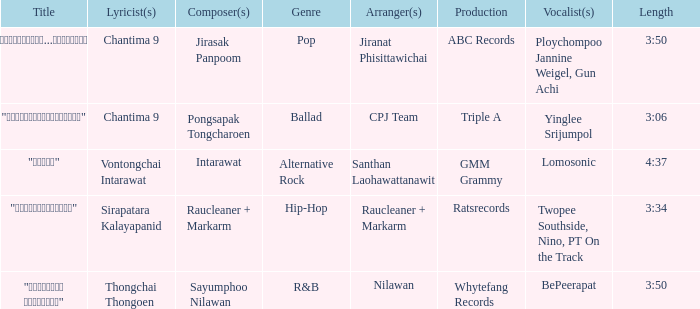Can you give me this table as a dict? {'header': ['Title', 'Lyricist(s)', 'Composer(s)', 'Genre', 'Arranger(s)', 'Production', 'Vocalist(s)', 'Length'], 'rows': [['"เรายังรักกัน...ไม่ใช่เหรอ"', 'Chantima 9', 'Jirasak Panpoom', 'Pop', 'Jiranat Phisittawichai', 'ABC Records', 'Ploychompoo Jannine Weigel, Gun Achi', '3:50'], ['"นางฟ้าตาชั้นเดียว"', 'Chantima 9', 'Pongsapak Tongcharoen', 'Ballad', 'CPJ Team', 'Triple A', 'Yinglee Srijumpol', '3:06'], ['"ขอโทษ"', 'Vontongchai Intarawat', 'Intarawat', 'Alternative Rock', 'Santhan Laohawattanawit', 'GMM Grammy', 'Lomosonic', '4:37'], ['"แค่อยากให้รู้"', 'Sirapatara Kalayapanid', 'Raucleaner + Markarm', 'Hip-Hop', 'Raucleaner + Markarm', 'Ratsrecords', 'Twopee Southside, Nino, PT On the Track', '3:34'], ['"เลือกลืม เลือกจำ"', 'Thongchai Thongoen', 'Sayumphoo Nilawan', 'R&B', 'Nilawan', 'Whytefang Records', 'BePeerapat', '3:50']]} Who was the arranger for the song that had a lyricist of Sirapatara Kalayapanid? Raucleaner + Markarm. 